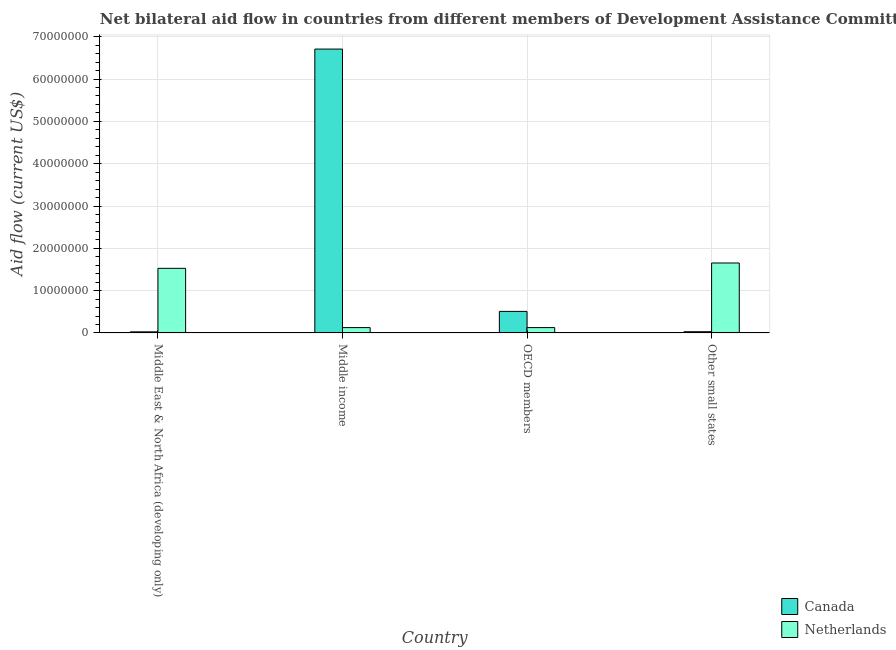What is the label of the 3rd group of bars from the left?
Your answer should be very brief. OECD members. In how many cases, is the number of bars for a given country not equal to the number of legend labels?
Ensure brevity in your answer.  0. What is the amount of aid given by canada in Other small states?
Provide a succinct answer. 2.90e+05. Across all countries, what is the maximum amount of aid given by netherlands?
Ensure brevity in your answer.  1.65e+07. Across all countries, what is the minimum amount of aid given by canada?
Your response must be concise. 2.60e+05. In which country was the amount of aid given by canada maximum?
Provide a short and direct response. Middle income. In which country was the amount of aid given by canada minimum?
Your answer should be compact. Middle East & North Africa (developing only). What is the total amount of aid given by netherlands in the graph?
Ensure brevity in your answer.  3.43e+07. What is the difference between the amount of aid given by netherlands in Middle income and that in Other small states?
Provide a succinct answer. -1.53e+07. What is the difference between the amount of aid given by canada in OECD members and the amount of aid given by netherlands in Other small states?
Offer a terse response. -1.14e+07. What is the average amount of aid given by netherlands per country?
Offer a very short reply. 8.58e+06. What is the difference between the amount of aid given by canada and amount of aid given by netherlands in Other small states?
Offer a very short reply. -1.62e+07. In how many countries, is the amount of aid given by netherlands greater than 32000000 US$?
Provide a succinct answer. 0. Is the amount of aid given by canada in Middle income less than that in Other small states?
Offer a very short reply. No. What is the difference between the highest and the second highest amount of aid given by canada?
Provide a succinct answer. 6.20e+07. What is the difference between the highest and the lowest amount of aid given by canada?
Your response must be concise. 6.68e+07. Is the sum of the amount of aid given by netherlands in OECD members and Other small states greater than the maximum amount of aid given by canada across all countries?
Give a very brief answer. No. What does the 1st bar from the left in OECD members represents?
Ensure brevity in your answer.  Canada. What does the 1st bar from the right in Middle income represents?
Ensure brevity in your answer.  Netherlands. Are all the bars in the graph horizontal?
Your response must be concise. No. Are the values on the major ticks of Y-axis written in scientific E-notation?
Provide a succinct answer. No. Does the graph contain grids?
Provide a short and direct response. Yes. How many legend labels are there?
Make the answer very short. 2. What is the title of the graph?
Offer a terse response. Net bilateral aid flow in countries from different members of Development Assistance Committee. What is the Aid flow (current US$) in Canada in Middle East & North Africa (developing only)?
Offer a very short reply. 2.60e+05. What is the Aid flow (current US$) in Netherlands in Middle East & North Africa (developing only)?
Ensure brevity in your answer.  1.53e+07. What is the Aid flow (current US$) of Canada in Middle income?
Keep it short and to the point. 6.71e+07. What is the Aid flow (current US$) of Netherlands in Middle income?
Ensure brevity in your answer.  1.26e+06. What is the Aid flow (current US$) of Canada in OECD members?
Provide a short and direct response. 5.09e+06. What is the Aid flow (current US$) in Netherlands in OECD members?
Provide a succinct answer. 1.26e+06. What is the Aid flow (current US$) in Canada in Other small states?
Ensure brevity in your answer.  2.90e+05. What is the Aid flow (current US$) of Netherlands in Other small states?
Provide a short and direct response. 1.65e+07. Across all countries, what is the maximum Aid flow (current US$) in Canada?
Offer a very short reply. 6.71e+07. Across all countries, what is the maximum Aid flow (current US$) of Netherlands?
Your response must be concise. 1.65e+07. Across all countries, what is the minimum Aid flow (current US$) in Canada?
Offer a terse response. 2.60e+05. Across all countries, what is the minimum Aid flow (current US$) in Netherlands?
Give a very brief answer. 1.26e+06. What is the total Aid flow (current US$) in Canada in the graph?
Keep it short and to the point. 7.27e+07. What is the total Aid flow (current US$) of Netherlands in the graph?
Offer a terse response. 3.43e+07. What is the difference between the Aid flow (current US$) in Canada in Middle East & North Africa (developing only) and that in Middle income?
Offer a terse response. -6.68e+07. What is the difference between the Aid flow (current US$) in Netherlands in Middle East & North Africa (developing only) and that in Middle income?
Provide a short and direct response. 1.40e+07. What is the difference between the Aid flow (current US$) in Canada in Middle East & North Africa (developing only) and that in OECD members?
Ensure brevity in your answer.  -4.83e+06. What is the difference between the Aid flow (current US$) in Netherlands in Middle East & North Africa (developing only) and that in OECD members?
Ensure brevity in your answer.  1.40e+07. What is the difference between the Aid flow (current US$) in Netherlands in Middle East & North Africa (developing only) and that in Other small states?
Offer a very short reply. -1.26e+06. What is the difference between the Aid flow (current US$) of Canada in Middle income and that in OECD members?
Offer a very short reply. 6.20e+07. What is the difference between the Aid flow (current US$) in Canada in Middle income and that in Other small states?
Offer a terse response. 6.68e+07. What is the difference between the Aid flow (current US$) in Netherlands in Middle income and that in Other small states?
Your answer should be very brief. -1.53e+07. What is the difference between the Aid flow (current US$) in Canada in OECD members and that in Other small states?
Offer a very short reply. 4.80e+06. What is the difference between the Aid flow (current US$) in Netherlands in OECD members and that in Other small states?
Offer a very short reply. -1.53e+07. What is the difference between the Aid flow (current US$) of Canada in Middle East & North Africa (developing only) and the Aid flow (current US$) of Netherlands in Other small states?
Offer a very short reply. -1.63e+07. What is the difference between the Aid flow (current US$) in Canada in Middle income and the Aid flow (current US$) in Netherlands in OECD members?
Your answer should be compact. 6.58e+07. What is the difference between the Aid flow (current US$) of Canada in Middle income and the Aid flow (current US$) of Netherlands in Other small states?
Offer a terse response. 5.06e+07. What is the difference between the Aid flow (current US$) in Canada in OECD members and the Aid flow (current US$) in Netherlands in Other small states?
Provide a short and direct response. -1.14e+07. What is the average Aid flow (current US$) of Canada per country?
Offer a very short reply. 1.82e+07. What is the average Aid flow (current US$) of Netherlands per country?
Offer a very short reply. 8.58e+06. What is the difference between the Aid flow (current US$) in Canada and Aid flow (current US$) in Netherlands in Middle East & North Africa (developing only)?
Provide a short and direct response. -1.50e+07. What is the difference between the Aid flow (current US$) in Canada and Aid flow (current US$) in Netherlands in Middle income?
Offer a very short reply. 6.58e+07. What is the difference between the Aid flow (current US$) of Canada and Aid flow (current US$) of Netherlands in OECD members?
Offer a terse response. 3.83e+06. What is the difference between the Aid flow (current US$) of Canada and Aid flow (current US$) of Netherlands in Other small states?
Your answer should be compact. -1.62e+07. What is the ratio of the Aid flow (current US$) of Canada in Middle East & North Africa (developing only) to that in Middle income?
Give a very brief answer. 0. What is the ratio of the Aid flow (current US$) of Netherlands in Middle East & North Africa (developing only) to that in Middle income?
Keep it short and to the point. 12.12. What is the ratio of the Aid flow (current US$) in Canada in Middle East & North Africa (developing only) to that in OECD members?
Provide a short and direct response. 0.05. What is the ratio of the Aid flow (current US$) of Netherlands in Middle East & North Africa (developing only) to that in OECD members?
Your answer should be very brief. 12.12. What is the ratio of the Aid flow (current US$) in Canada in Middle East & North Africa (developing only) to that in Other small states?
Make the answer very short. 0.9. What is the ratio of the Aid flow (current US$) in Netherlands in Middle East & North Africa (developing only) to that in Other small states?
Your answer should be compact. 0.92. What is the ratio of the Aid flow (current US$) in Canada in Middle income to that in OECD members?
Your response must be concise. 13.18. What is the ratio of the Aid flow (current US$) of Canada in Middle income to that in Other small states?
Ensure brevity in your answer.  231.34. What is the ratio of the Aid flow (current US$) in Netherlands in Middle income to that in Other small states?
Offer a terse response. 0.08. What is the ratio of the Aid flow (current US$) of Canada in OECD members to that in Other small states?
Keep it short and to the point. 17.55. What is the ratio of the Aid flow (current US$) of Netherlands in OECD members to that in Other small states?
Your answer should be compact. 0.08. What is the difference between the highest and the second highest Aid flow (current US$) in Canada?
Offer a terse response. 6.20e+07. What is the difference between the highest and the second highest Aid flow (current US$) of Netherlands?
Your answer should be very brief. 1.26e+06. What is the difference between the highest and the lowest Aid flow (current US$) in Canada?
Ensure brevity in your answer.  6.68e+07. What is the difference between the highest and the lowest Aid flow (current US$) of Netherlands?
Offer a very short reply. 1.53e+07. 